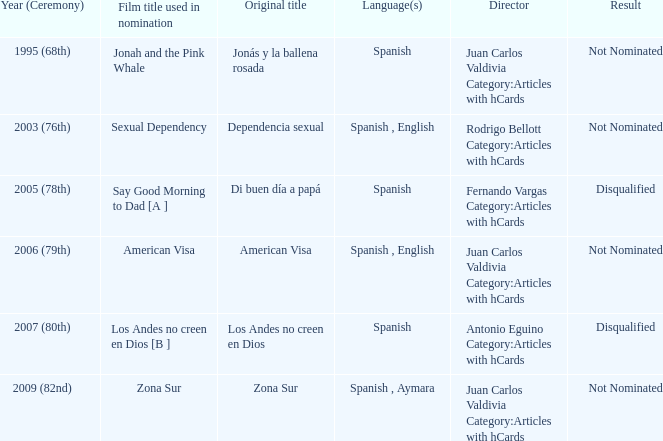What was the consequence for zona sur after their nomination consideration? Not Nominated. 